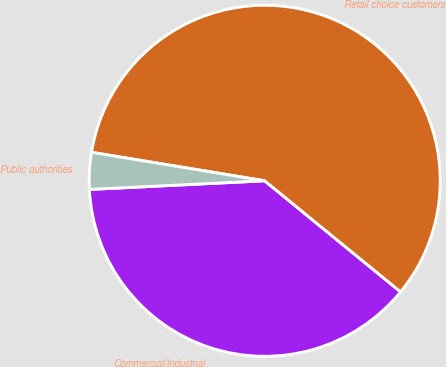Convert chart. <chart><loc_0><loc_0><loc_500><loc_500><pie_chart><fcel>Commercial/Industrial<fcel>Retail choice customers<fcel>Public authorities<nl><fcel>38.31%<fcel>58.31%<fcel>3.38%<nl></chart> 